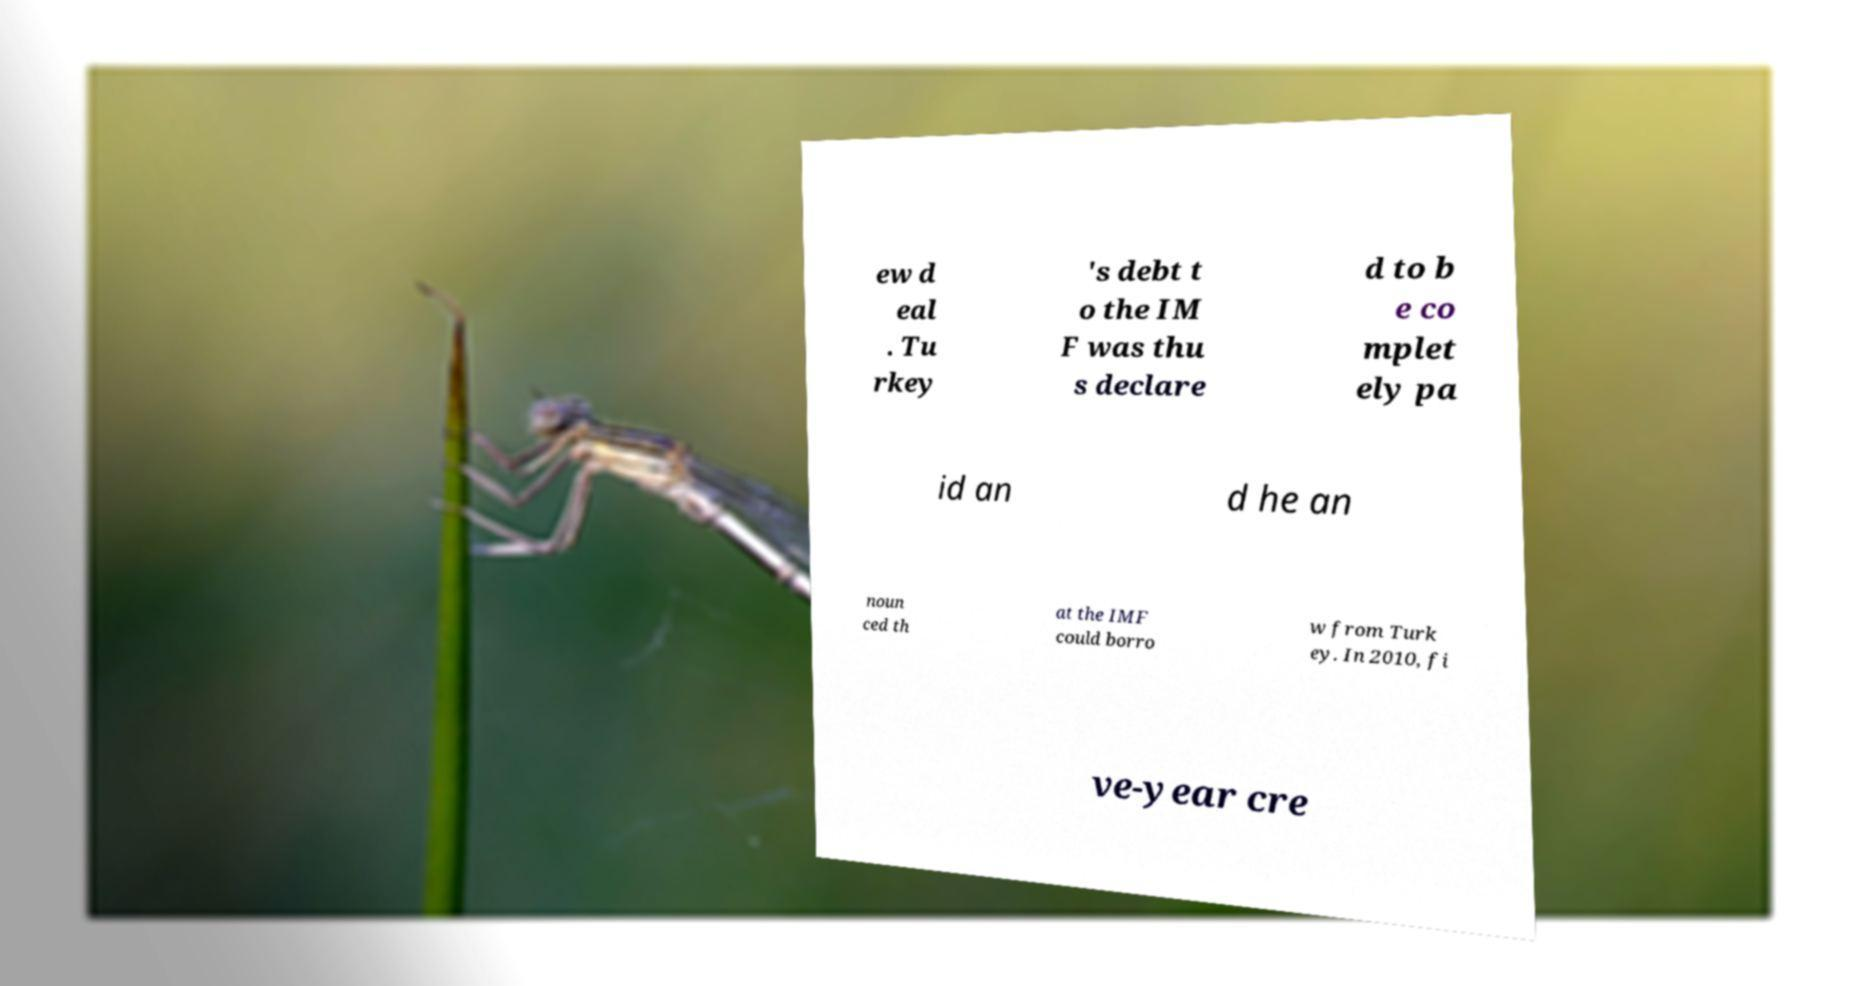What messages or text are displayed in this image? I need them in a readable, typed format. ew d eal . Tu rkey 's debt t o the IM F was thu s declare d to b e co mplet ely pa id an d he an noun ced th at the IMF could borro w from Turk ey. In 2010, fi ve-year cre 